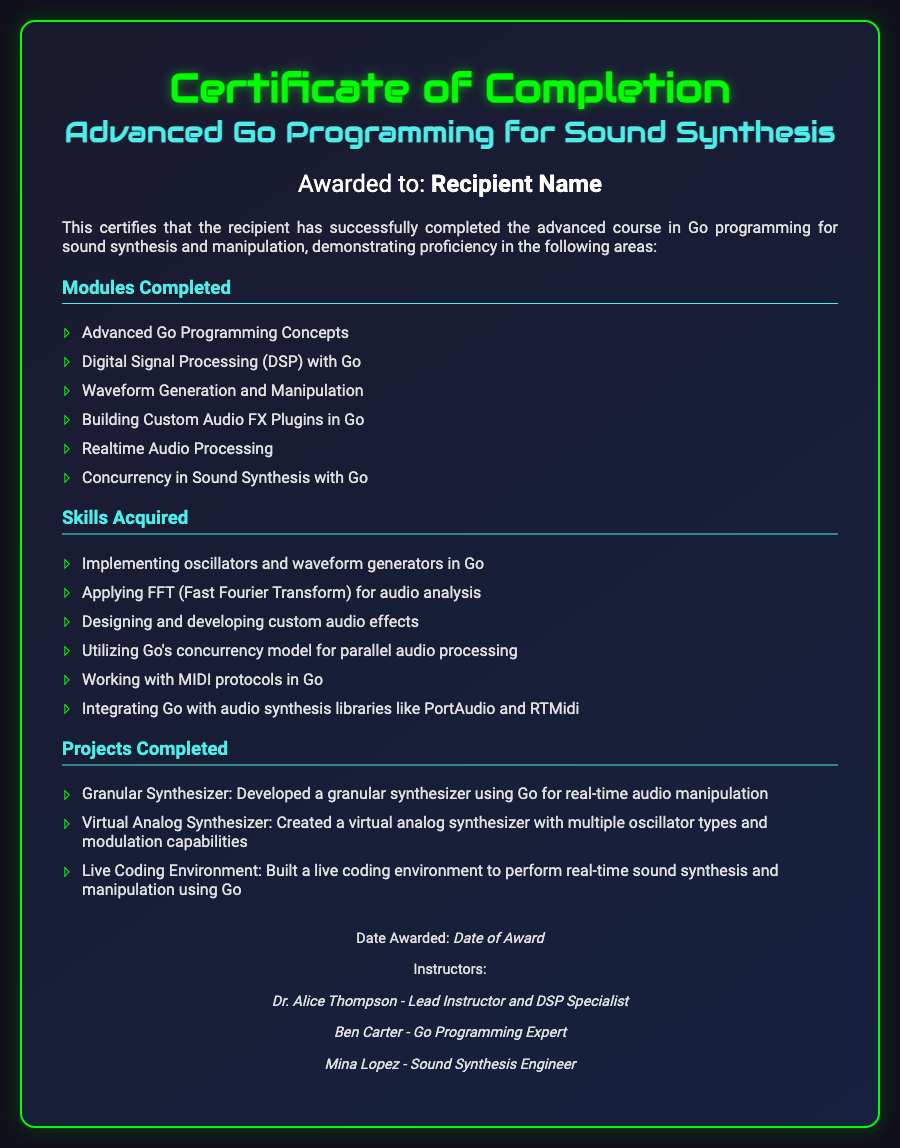What is the title of the course? The title of the course is presented in the heading of the certificate.
Answer: Advanced Go Programming for Sound Synthesis Who is the recipient of the certificate? The recipient's name is mentioned on the certificate under the "Awarded to" section.
Answer: Recipient Name What is the date awarded? The date awarded is indicated in the footer section of the certificate.
Answer: Date of Award How many modules were completed? The number of modules can be inferred from the list of modules presented in the document.
Answer: Six Which module focuses on audio analysis? This module is specifically mentioned in the "Modules Completed" section.
Answer: Digital Signal Processing (DSP) with Go Who is the lead instructor? The name of the lead instructor is listed in the footer of the certificate.
Answer: Dr. Alice Thompson What type of synthesizer was developed as a project? The type of synthesizer is mentioned in the "Projects Completed" section.
Answer: Granular Synthesizer What skill involves Go’s concurrency model? The specific skill related to concurrency is highlighted in the "Skills Acquired" section.
Answer: Utilizing Go's concurrency model for parallel audio processing How many instructors are listed on the certificate? The total number of instructors can be counted in the footer section of the document.
Answer: Three 